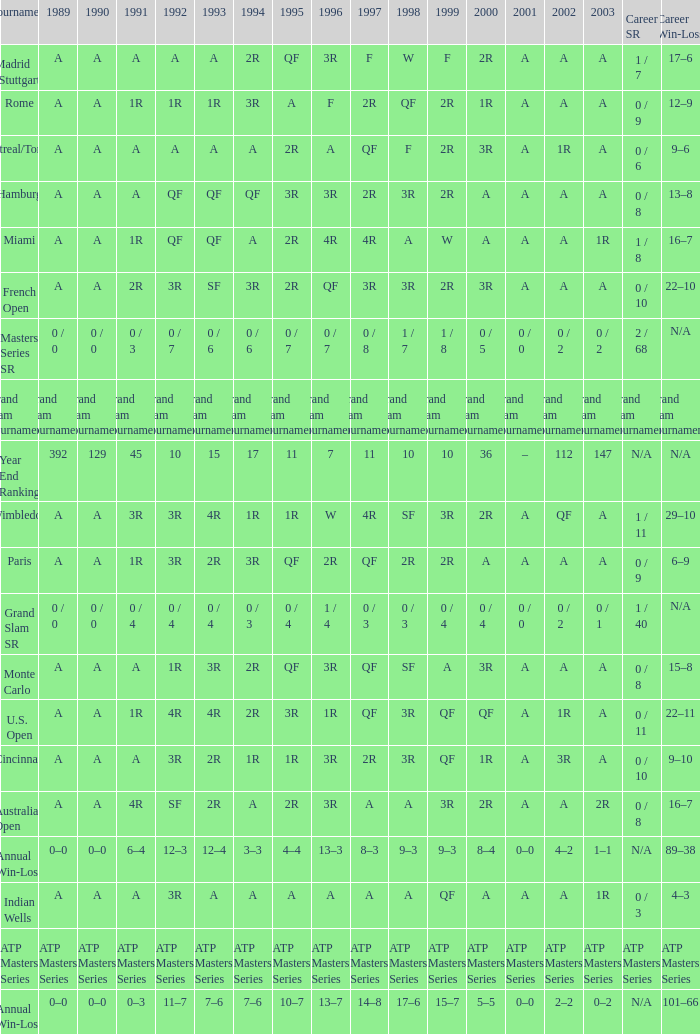What is the value in 1997 when the value in 1989 is A, 1995 is QF, 1996 is 3R and the career SR is 0 / 8? QF. 